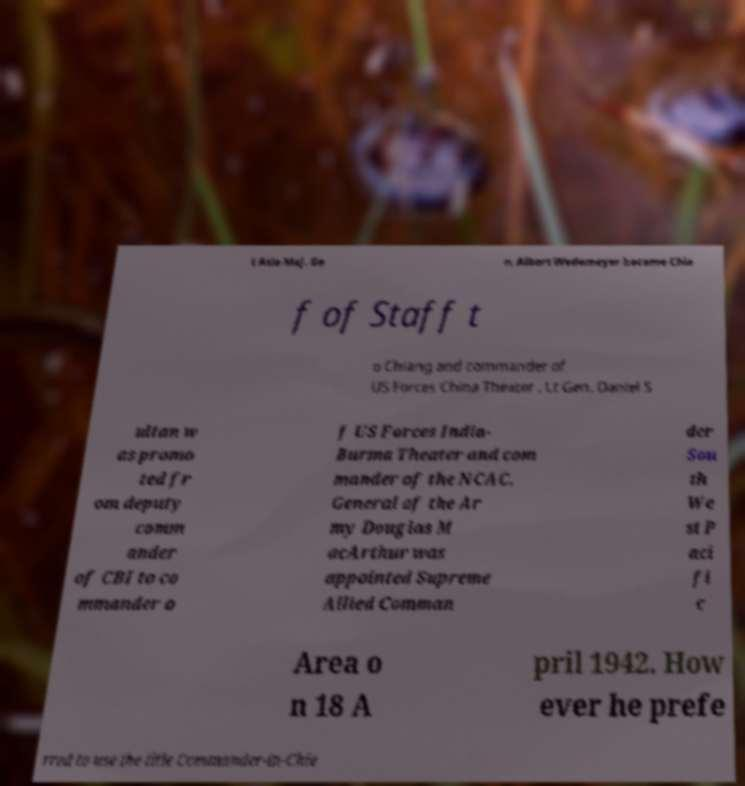Could you extract and type out the text from this image? t Asia Maj. Ge n. Albert Wedemeyer became Chie f of Staff t o Chiang and commander of US Forces China Theater . Lt Gen. Daniel S ultan w as promo ted fr om deputy comm ander of CBI to co mmander o f US Forces India- Burma Theater and com mander of the NCAC. General of the Ar my Douglas M acArthur was appointed Supreme Allied Comman der Sou th We st P aci fi c Area o n 18 A pril 1942. How ever he prefe rred to use the title Commander-in-Chie 